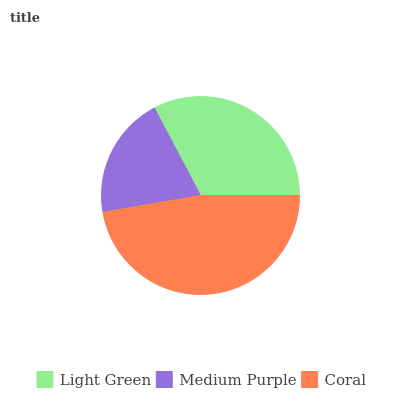Is Medium Purple the minimum?
Answer yes or no. Yes. Is Coral the maximum?
Answer yes or no. Yes. Is Coral the minimum?
Answer yes or no. No. Is Medium Purple the maximum?
Answer yes or no. No. Is Coral greater than Medium Purple?
Answer yes or no. Yes. Is Medium Purple less than Coral?
Answer yes or no. Yes. Is Medium Purple greater than Coral?
Answer yes or no. No. Is Coral less than Medium Purple?
Answer yes or no. No. Is Light Green the high median?
Answer yes or no. Yes. Is Light Green the low median?
Answer yes or no. Yes. Is Coral the high median?
Answer yes or no. No. Is Coral the low median?
Answer yes or no. No. 